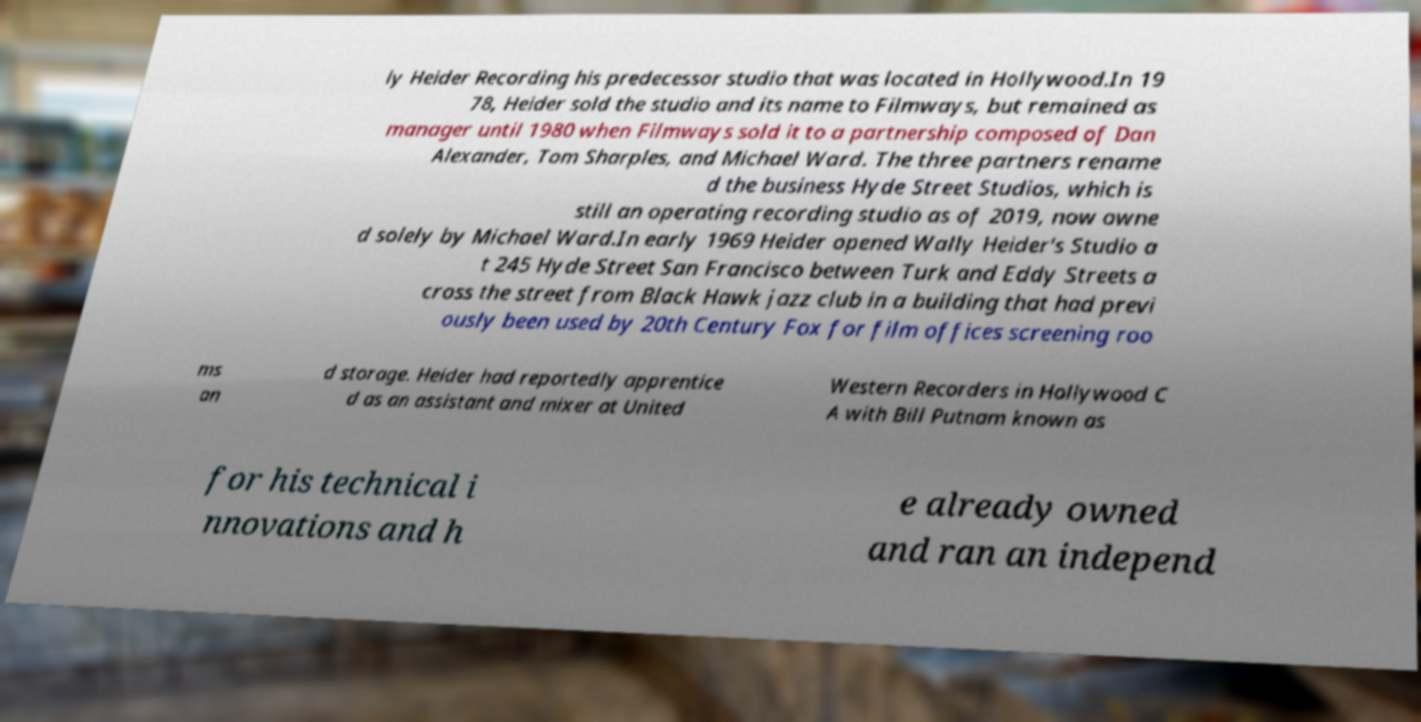What messages or text are displayed in this image? I need them in a readable, typed format. ly Heider Recording his predecessor studio that was located in Hollywood.In 19 78, Heider sold the studio and its name to Filmways, but remained as manager until 1980 when Filmways sold it to a partnership composed of Dan Alexander, Tom Sharples, and Michael Ward. The three partners rename d the business Hyde Street Studios, which is still an operating recording studio as of 2019, now owne d solely by Michael Ward.In early 1969 Heider opened Wally Heider's Studio a t 245 Hyde Street San Francisco between Turk and Eddy Streets a cross the street from Black Hawk jazz club in a building that had previ ously been used by 20th Century Fox for film offices screening roo ms an d storage. Heider had reportedly apprentice d as an assistant and mixer at United Western Recorders in Hollywood C A with Bill Putnam known as for his technical i nnovations and h e already owned and ran an independ 